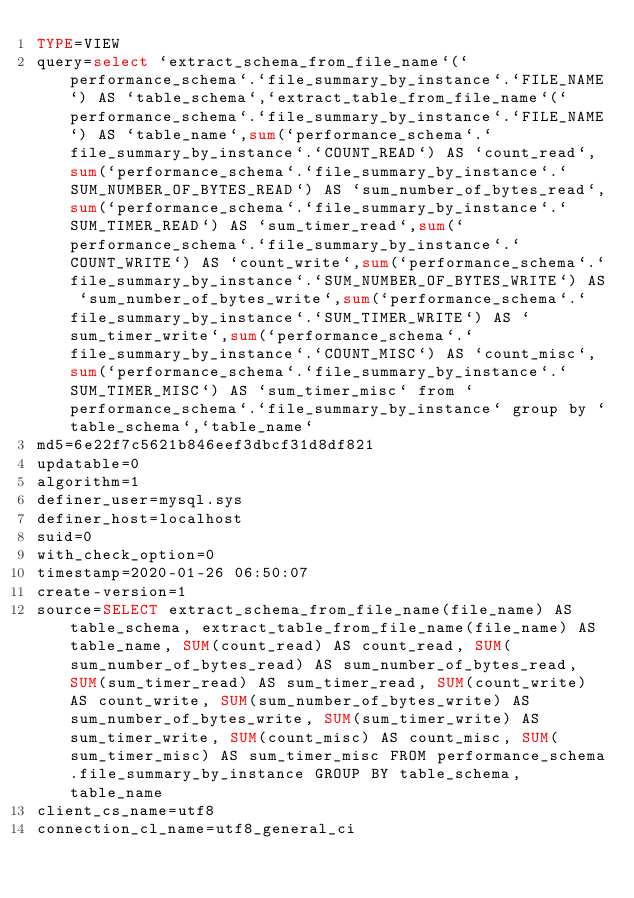<code> <loc_0><loc_0><loc_500><loc_500><_VisualBasic_>TYPE=VIEW
query=select `extract_schema_from_file_name`(`performance_schema`.`file_summary_by_instance`.`FILE_NAME`) AS `table_schema`,`extract_table_from_file_name`(`performance_schema`.`file_summary_by_instance`.`FILE_NAME`) AS `table_name`,sum(`performance_schema`.`file_summary_by_instance`.`COUNT_READ`) AS `count_read`,sum(`performance_schema`.`file_summary_by_instance`.`SUM_NUMBER_OF_BYTES_READ`) AS `sum_number_of_bytes_read`,sum(`performance_schema`.`file_summary_by_instance`.`SUM_TIMER_READ`) AS `sum_timer_read`,sum(`performance_schema`.`file_summary_by_instance`.`COUNT_WRITE`) AS `count_write`,sum(`performance_schema`.`file_summary_by_instance`.`SUM_NUMBER_OF_BYTES_WRITE`) AS `sum_number_of_bytes_write`,sum(`performance_schema`.`file_summary_by_instance`.`SUM_TIMER_WRITE`) AS `sum_timer_write`,sum(`performance_schema`.`file_summary_by_instance`.`COUNT_MISC`) AS `count_misc`,sum(`performance_schema`.`file_summary_by_instance`.`SUM_TIMER_MISC`) AS `sum_timer_misc` from `performance_schema`.`file_summary_by_instance` group by `table_schema`,`table_name`
md5=6e22f7c5621b846eef3dbcf31d8df821
updatable=0
algorithm=1
definer_user=mysql.sys
definer_host=localhost
suid=0
with_check_option=0
timestamp=2020-01-26 06:50:07
create-version=1
source=SELECT extract_schema_from_file_name(file_name) AS table_schema, extract_table_from_file_name(file_name) AS table_name, SUM(count_read) AS count_read, SUM(sum_number_of_bytes_read) AS sum_number_of_bytes_read, SUM(sum_timer_read) AS sum_timer_read, SUM(count_write) AS count_write, SUM(sum_number_of_bytes_write) AS sum_number_of_bytes_write, SUM(sum_timer_write) AS sum_timer_write, SUM(count_misc) AS count_misc, SUM(sum_timer_misc) AS sum_timer_misc FROM performance_schema.file_summary_by_instance GROUP BY table_schema, table_name
client_cs_name=utf8
connection_cl_name=utf8_general_ci</code> 